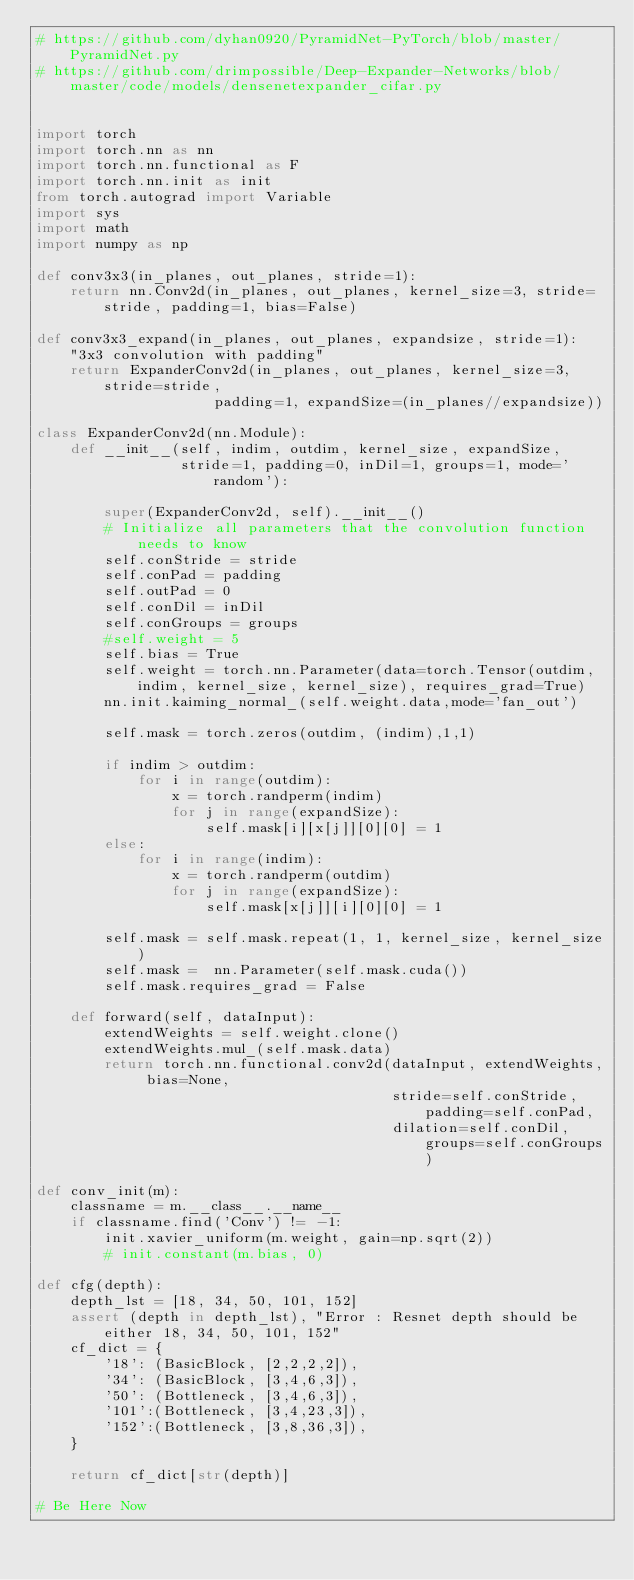Convert code to text. <code><loc_0><loc_0><loc_500><loc_500><_Python_># https://github.com/dyhan0920/PyramidNet-PyTorch/blob/master/PyramidNet.py
# https://github.com/drimpossible/Deep-Expander-Networks/blob/master/code/models/densenetexpander_cifar.py


import torch
import torch.nn as nn
import torch.nn.functional as F
import torch.nn.init as init
from torch.autograd import Variable
import sys
import math
import numpy as np

def conv3x3(in_planes, out_planes, stride=1):
    return nn.Conv2d(in_planes, out_planes, kernel_size=3, stride=stride, padding=1, bias=False)

def conv3x3_expand(in_planes, out_planes, expandsize, stride=1):
    "3x3 convolution with padding"
    return ExpanderConv2d(in_planes, out_planes, kernel_size=3, stride=stride,
                     padding=1, expandSize=(in_planes//expandsize))

class ExpanderConv2d(nn.Module):
    def __init__(self, indim, outdim, kernel_size, expandSize,
                 stride=1, padding=0, inDil=1, groups=1, mode='random'):

        super(ExpanderConv2d, self).__init__()
        # Initialize all parameters that the convolution function needs to know
        self.conStride = stride
        self.conPad = padding
        self.outPad = 0
        self.conDil = inDil
        self.conGroups = groups
        #self.weight = 5
        self.bias = True
        self.weight = torch.nn.Parameter(data=torch.Tensor(outdim, indim, kernel_size, kernel_size), requires_grad=True)
        nn.init.kaiming_normal_(self.weight.data,mode='fan_out')

        self.mask = torch.zeros(outdim, (indim),1,1)

        if indim > outdim:
            for i in range(outdim):
                x = torch.randperm(indim)
                for j in range(expandSize):
                    self.mask[i][x[j]][0][0] = 1
        else:
            for i in range(indim):
                x = torch.randperm(outdim)
                for j in range(expandSize):
                    self.mask[x[j]][i][0][0] = 1

        self.mask = self.mask.repeat(1, 1, kernel_size, kernel_size)
        self.mask =  nn.Parameter(self.mask.cuda())
        self.mask.requires_grad = False

    def forward(self, dataInput):
        extendWeights = self.weight.clone()
        extendWeights.mul_(self.mask.data)
        return torch.nn.functional.conv2d(dataInput, extendWeights, bias=None,
                                          stride=self.conStride, padding=self.conPad,
                                          dilation=self.conDil, groups=self.conGroups)

def conv_init(m):
    classname = m.__class__.__name__
    if classname.find('Conv') != -1:
        init.xavier_uniform(m.weight, gain=np.sqrt(2))
        # init.constant(m.bias, 0)

def cfg(depth):
    depth_lst = [18, 34, 50, 101, 152]
    assert (depth in depth_lst), "Error : Resnet depth should be either 18, 34, 50, 101, 152"
    cf_dict = {
        '18': (BasicBlock, [2,2,2,2]),
        '34': (BasicBlock, [3,4,6,3]),
        '50': (Bottleneck, [3,4,6,3]),
        '101':(Bottleneck, [3,4,23,3]),
        '152':(Bottleneck, [3,8,36,3]),
    }

    return cf_dict[str(depth)]

# Be Here Now 
</code> 